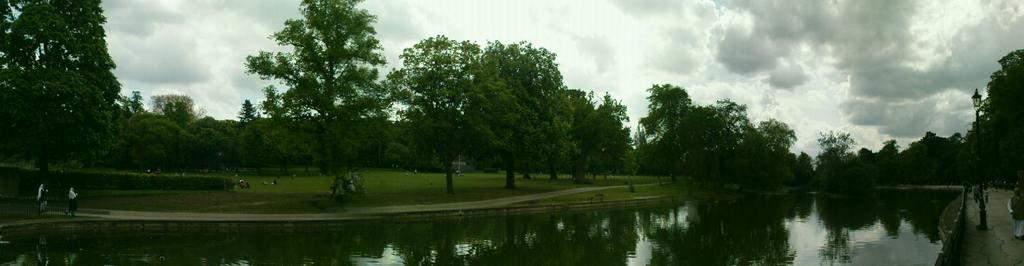Can you describe this image briefly? In this image in the center there is water lake. On the right side of the lake there is a pole, and there are trees, and there are persons and in the center there are trees and there are persons and there is grass on the ground and the sky is cloudy. 